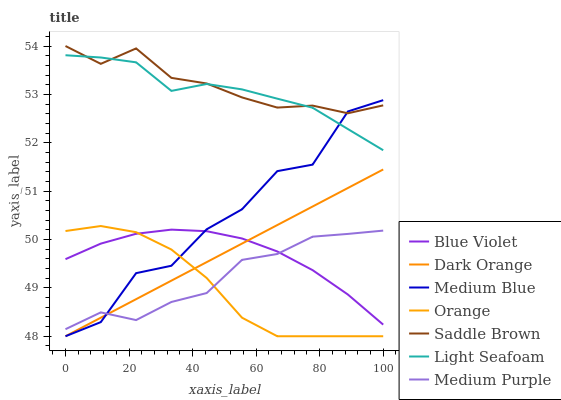Does Orange have the minimum area under the curve?
Answer yes or no. Yes. Does Saddle Brown have the maximum area under the curve?
Answer yes or no. Yes. Does Medium Blue have the minimum area under the curve?
Answer yes or no. No. Does Medium Blue have the maximum area under the curve?
Answer yes or no. No. Is Dark Orange the smoothest?
Answer yes or no. Yes. Is Medium Blue the roughest?
Answer yes or no. Yes. Is Medium Purple the smoothest?
Answer yes or no. No. Is Medium Purple the roughest?
Answer yes or no. No. Does Dark Orange have the lowest value?
Answer yes or no. Yes. Does Medium Purple have the lowest value?
Answer yes or no. No. Does Saddle Brown have the highest value?
Answer yes or no. Yes. Does Medium Blue have the highest value?
Answer yes or no. No. Is Orange less than Light Seafoam?
Answer yes or no. Yes. Is Saddle Brown greater than Blue Violet?
Answer yes or no. Yes. Does Medium Purple intersect Medium Blue?
Answer yes or no. Yes. Is Medium Purple less than Medium Blue?
Answer yes or no. No. Is Medium Purple greater than Medium Blue?
Answer yes or no. No. Does Orange intersect Light Seafoam?
Answer yes or no. No. 